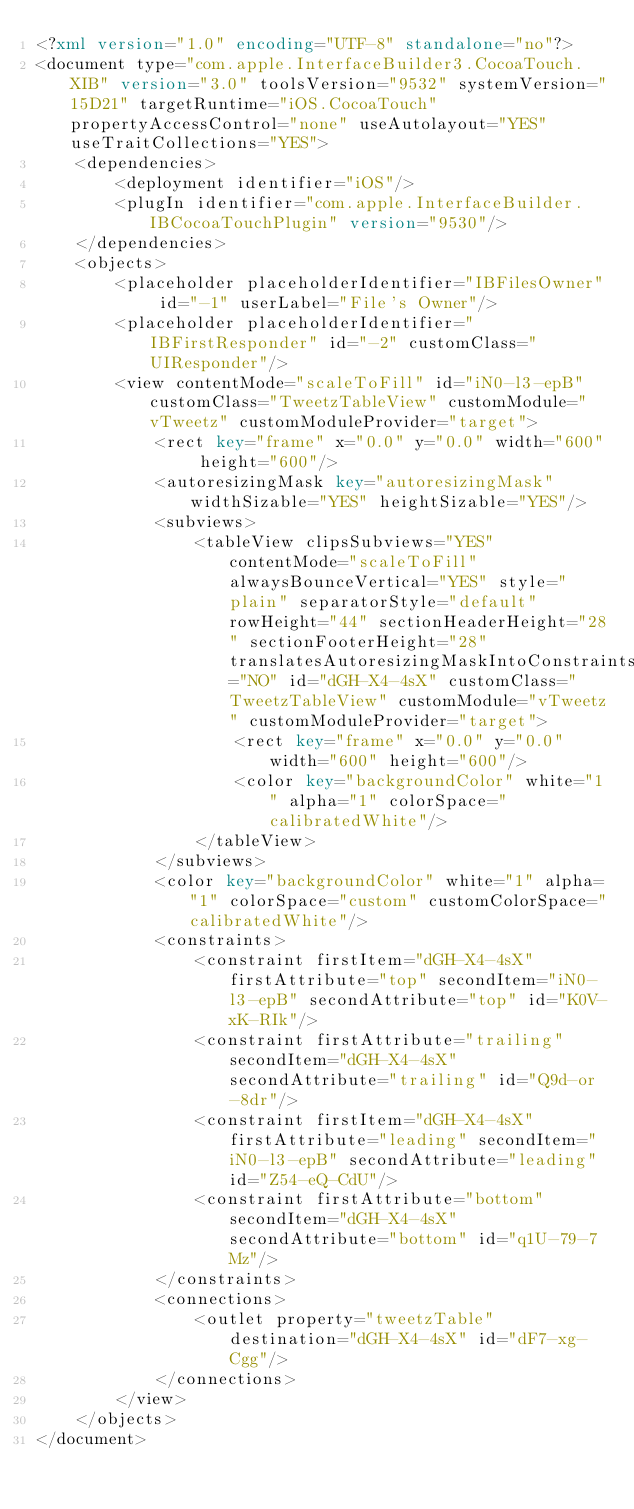Convert code to text. <code><loc_0><loc_0><loc_500><loc_500><_XML_><?xml version="1.0" encoding="UTF-8" standalone="no"?>
<document type="com.apple.InterfaceBuilder3.CocoaTouch.XIB" version="3.0" toolsVersion="9532" systemVersion="15D21" targetRuntime="iOS.CocoaTouch" propertyAccessControl="none" useAutolayout="YES" useTraitCollections="YES">
    <dependencies>
        <deployment identifier="iOS"/>
        <plugIn identifier="com.apple.InterfaceBuilder.IBCocoaTouchPlugin" version="9530"/>
    </dependencies>
    <objects>
        <placeholder placeholderIdentifier="IBFilesOwner" id="-1" userLabel="File's Owner"/>
        <placeholder placeholderIdentifier="IBFirstResponder" id="-2" customClass="UIResponder"/>
        <view contentMode="scaleToFill" id="iN0-l3-epB" customClass="TweetzTableView" customModule="vTweetz" customModuleProvider="target">
            <rect key="frame" x="0.0" y="0.0" width="600" height="600"/>
            <autoresizingMask key="autoresizingMask" widthSizable="YES" heightSizable="YES"/>
            <subviews>
                <tableView clipsSubviews="YES" contentMode="scaleToFill" alwaysBounceVertical="YES" style="plain" separatorStyle="default" rowHeight="44" sectionHeaderHeight="28" sectionFooterHeight="28" translatesAutoresizingMaskIntoConstraints="NO" id="dGH-X4-4sX" customClass="TweetzTableView" customModule="vTweetz" customModuleProvider="target">
                    <rect key="frame" x="0.0" y="0.0" width="600" height="600"/>
                    <color key="backgroundColor" white="1" alpha="1" colorSpace="calibratedWhite"/>
                </tableView>
            </subviews>
            <color key="backgroundColor" white="1" alpha="1" colorSpace="custom" customColorSpace="calibratedWhite"/>
            <constraints>
                <constraint firstItem="dGH-X4-4sX" firstAttribute="top" secondItem="iN0-l3-epB" secondAttribute="top" id="K0V-xK-RIk"/>
                <constraint firstAttribute="trailing" secondItem="dGH-X4-4sX" secondAttribute="trailing" id="Q9d-or-8dr"/>
                <constraint firstItem="dGH-X4-4sX" firstAttribute="leading" secondItem="iN0-l3-epB" secondAttribute="leading" id="Z54-eQ-CdU"/>
                <constraint firstAttribute="bottom" secondItem="dGH-X4-4sX" secondAttribute="bottom" id="q1U-79-7Mz"/>
            </constraints>
            <connections>
                <outlet property="tweetzTable" destination="dGH-X4-4sX" id="dF7-xg-Cgg"/>
            </connections>
        </view>
    </objects>
</document>
</code> 